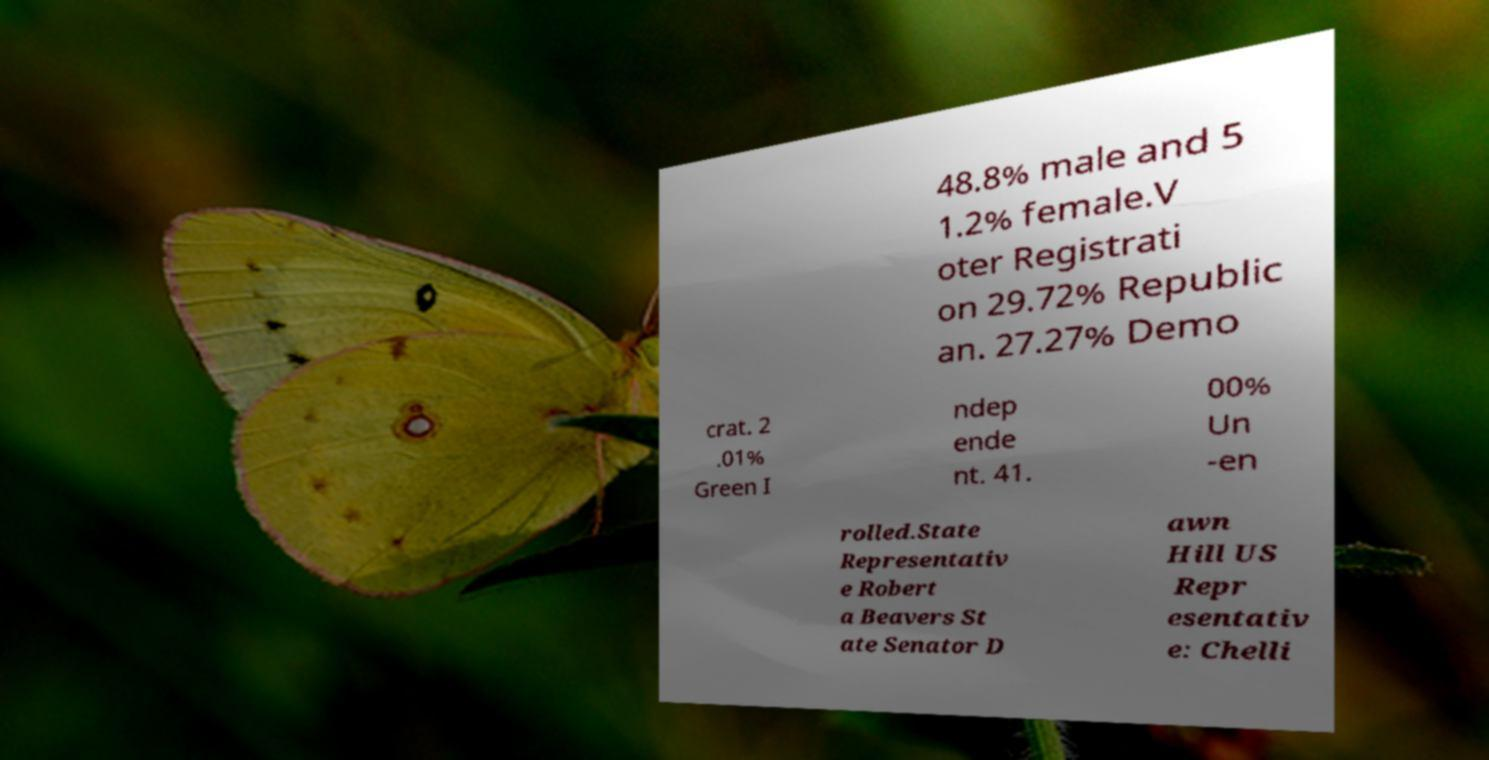For documentation purposes, I need the text within this image transcribed. Could you provide that? 48.8% male and 5 1.2% female.V oter Registrati on 29.72% Republic an. 27.27% Demo crat. 2 .01% Green I ndep ende nt. 41. 00% Un -en rolled.State Representativ e Robert a Beavers St ate Senator D awn Hill US Repr esentativ e: Chelli 